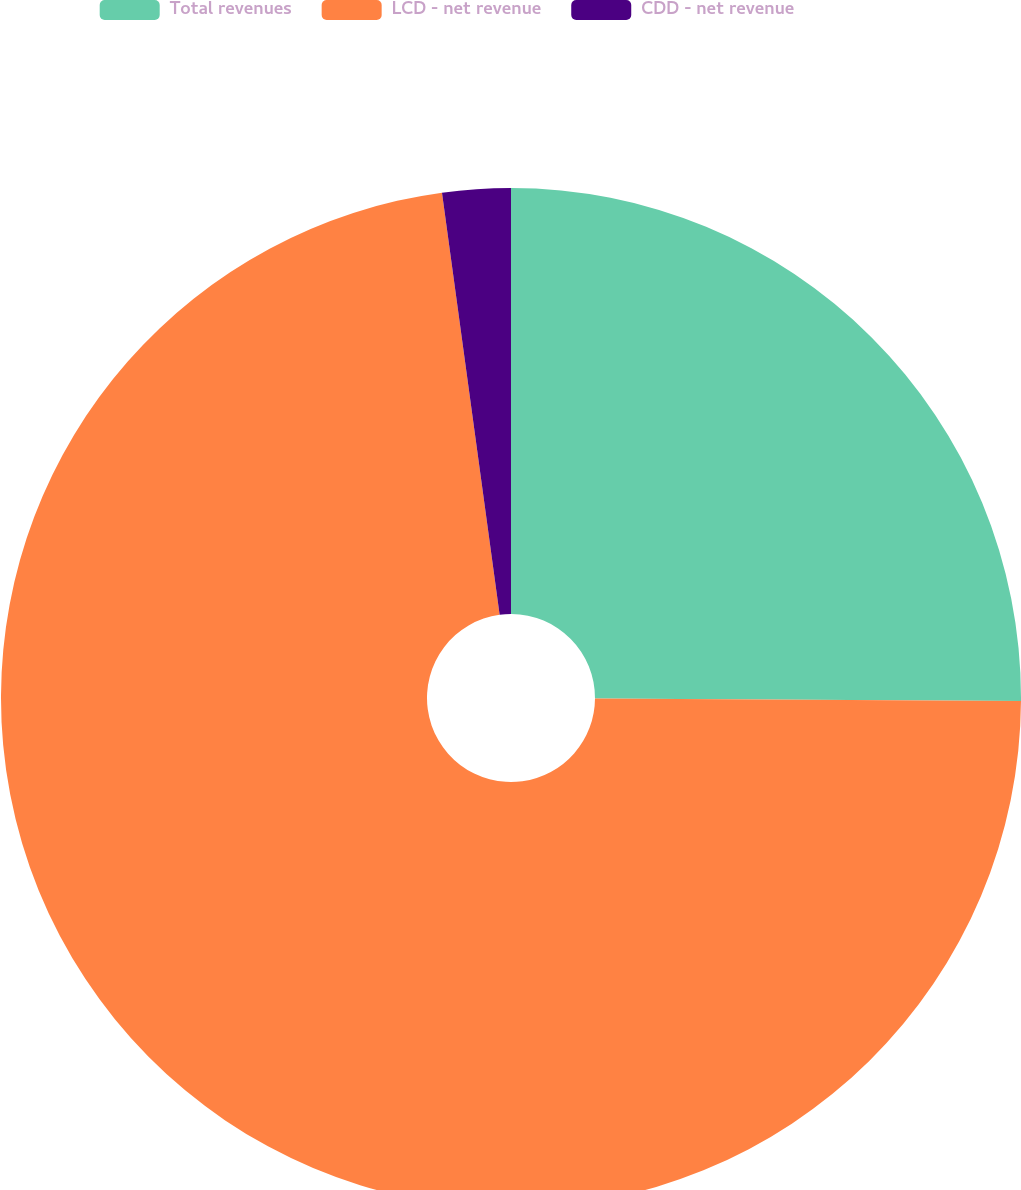Convert chart. <chart><loc_0><loc_0><loc_500><loc_500><pie_chart><fcel>Total revenues<fcel>LCD - net revenue<fcel>CDD - net revenue<nl><fcel>25.09%<fcel>72.74%<fcel>2.16%<nl></chart> 